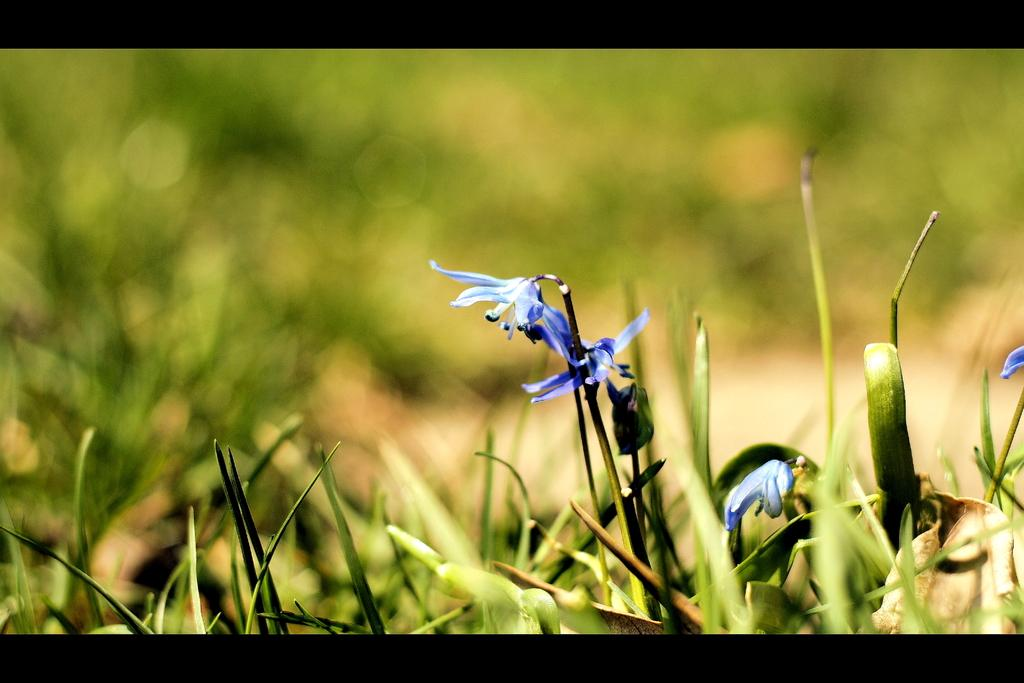What type of living organisms can be seen in the image? Plants and flowers are visible in the image. What color are the flowers in the image? The flowers in the image are purple in color. What type of meat is being prepared in the image? There is no meat present in the image; it features plants and flowers. What act is being performed by the plants in the image? Plants do not perform acts; they are living organisms that grow and produce flowers. 